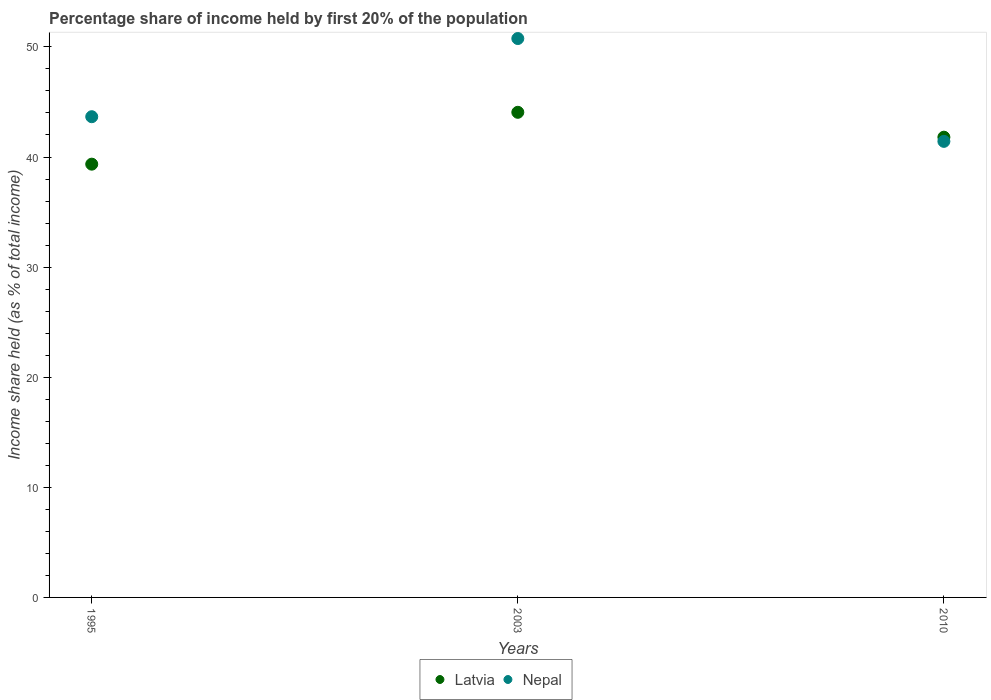How many different coloured dotlines are there?
Make the answer very short. 2. Is the number of dotlines equal to the number of legend labels?
Offer a very short reply. Yes. What is the share of income held by first 20% of the population in Nepal in 2003?
Your response must be concise. 50.76. Across all years, what is the maximum share of income held by first 20% of the population in Nepal?
Give a very brief answer. 50.76. Across all years, what is the minimum share of income held by first 20% of the population in Nepal?
Your answer should be very brief. 41.42. In which year was the share of income held by first 20% of the population in Latvia maximum?
Give a very brief answer. 2003. In which year was the share of income held by first 20% of the population in Nepal minimum?
Give a very brief answer. 2010. What is the total share of income held by first 20% of the population in Latvia in the graph?
Offer a very short reply. 125.21. What is the difference between the share of income held by first 20% of the population in Nepal in 1995 and that in 2003?
Offer a terse response. -7.1. What is the difference between the share of income held by first 20% of the population in Latvia in 2003 and the share of income held by first 20% of the population in Nepal in 1995?
Ensure brevity in your answer.  0.4. What is the average share of income held by first 20% of the population in Nepal per year?
Provide a succinct answer. 45.28. In the year 2010, what is the difference between the share of income held by first 20% of the population in Latvia and share of income held by first 20% of the population in Nepal?
Keep it short and to the point. 0.38. In how many years, is the share of income held by first 20% of the population in Nepal greater than 12 %?
Offer a terse response. 3. What is the ratio of the share of income held by first 20% of the population in Nepal in 2003 to that in 2010?
Your response must be concise. 1.23. Is the share of income held by first 20% of the population in Latvia in 1995 less than that in 2010?
Provide a succinct answer. Yes. Is the difference between the share of income held by first 20% of the population in Latvia in 1995 and 2010 greater than the difference between the share of income held by first 20% of the population in Nepal in 1995 and 2010?
Your response must be concise. No. What is the difference between the highest and the second highest share of income held by first 20% of the population in Latvia?
Provide a short and direct response. 2.26. What is the difference between the highest and the lowest share of income held by first 20% of the population in Latvia?
Make the answer very short. 4.71. Does the share of income held by first 20% of the population in Latvia monotonically increase over the years?
Give a very brief answer. No. Is the share of income held by first 20% of the population in Latvia strictly greater than the share of income held by first 20% of the population in Nepal over the years?
Provide a short and direct response. No. How many years are there in the graph?
Offer a very short reply. 3. Are the values on the major ticks of Y-axis written in scientific E-notation?
Ensure brevity in your answer.  No. Where does the legend appear in the graph?
Offer a terse response. Bottom center. How many legend labels are there?
Keep it short and to the point. 2. How are the legend labels stacked?
Provide a succinct answer. Horizontal. What is the title of the graph?
Give a very brief answer. Percentage share of income held by first 20% of the population. What is the label or title of the Y-axis?
Offer a very short reply. Income share held (as % of total income). What is the Income share held (as % of total income) of Latvia in 1995?
Your response must be concise. 39.35. What is the Income share held (as % of total income) of Nepal in 1995?
Make the answer very short. 43.66. What is the Income share held (as % of total income) of Latvia in 2003?
Provide a short and direct response. 44.06. What is the Income share held (as % of total income) of Nepal in 2003?
Keep it short and to the point. 50.76. What is the Income share held (as % of total income) of Latvia in 2010?
Your answer should be very brief. 41.8. What is the Income share held (as % of total income) of Nepal in 2010?
Offer a terse response. 41.42. Across all years, what is the maximum Income share held (as % of total income) of Latvia?
Your answer should be very brief. 44.06. Across all years, what is the maximum Income share held (as % of total income) in Nepal?
Offer a terse response. 50.76. Across all years, what is the minimum Income share held (as % of total income) of Latvia?
Your answer should be compact. 39.35. Across all years, what is the minimum Income share held (as % of total income) of Nepal?
Offer a very short reply. 41.42. What is the total Income share held (as % of total income) of Latvia in the graph?
Make the answer very short. 125.21. What is the total Income share held (as % of total income) of Nepal in the graph?
Your answer should be compact. 135.84. What is the difference between the Income share held (as % of total income) in Latvia in 1995 and that in 2003?
Give a very brief answer. -4.71. What is the difference between the Income share held (as % of total income) in Nepal in 1995 and that in 2003?
Give a very brief answer. -7.1. What is the difference between the Income share held (as % of total income) of Latvia in 1995 and that in 2010?
Give a very brief answer. -2.45. What is the difference between the Income share held (as % of total income) of Nepal in 1995 and that in 2010?
Ensure brevity in your answer.  2.24. What is the difference between the Income share held (as % of total income) in Latvia in 2003 and that in 2010?
Ensure brevity in your answer.  2.26. What is the difference between the Income share held (as % of total income) in Nepal in 2003 and that in 2010?
Make the answer very short. 9.34. What is the difference between the Income share held (as % of total income) in Latvia in 1995 and the Income share held (as % of total income) in Nepal in 2003?
Give a very brief answer. -11.41. What is the difference between the Income share held (as % of total income) of Latvia in 1995 and the Income share held (as % of total income) of Nepal in 2010?
Offer a terse response. -2.07. What is the difference between the Income share held (as % of total income) in Latvia in 2003 and the Income share held (as % of total income) in Nepal in 2010?
Your response must be concise. 2.64. What is the average Income share held (as % of total income) of Latvia per year?
Keep it short and to the point. 41.74. What is the average Income share held (as % of total income) of Nepal per year?
Your answer should be compact. 45.28. In the year 1995, what is the difference between the Income share held (as % of total income) of Latvia and Income share held (as % of total income) of Nepal?
Ensure brevity in your answer.  -4.31. In the year 2003, what is the difference between the Income share held (as % of total income) of Latvia and Income share held (as % of total income) of Nepal?
Provide a succinct answer. -6.7. In the year 2010, what is the difference between the Income share held (as % of total income) of Latvia and Income share held (as % of total income) of Nepal?
Your response must be concise. 0.38. What is the ratio of the Income share held (as % of total income) in Latvia in 1995 to that in 2003?
Ensure brevity in your answer.  0.89. What is the ratio of the Income share held (as % of total income) of Nepal in 1995 to that in 2003?
Your answer should be very brief. 0.86. What is the ratio of the Income share held (as % of total income) of Latvia in 1995 to that in 2010?
Your answer should be very brief. 0.94. What is the ratio of the Income share held (as % of total income) of Nepal in 1995 to that in 2010?
Provide a short and direct response. 1.05. What is the ratio of the Income share held (as % of total income) in Latvia in 2003 to that in 2010?
Provide a succinct answer. 1.05. What is the ratio of the Income share held (as % of total income) in Nepal in 2003 to that in 2010?
Ensure brevity in your answer.  1.23. What is the difference between the highest and the second highest Income share held (as % of total income) in Latvia?
Give a very brief answer. 2.26. What is the difference between the highest and the second highest Income share held (as % of total income) in Nepal?
Keep it short and to the point. 7.1. What is the difference between the highest and the lowest Income share held (as % of total income) in Latvia?
Offer a terse response. 4.71. What is the difference between the highest and the lowest Income share held (as % of total income) in Nepal?
Offer a very short reply. 9.34. 